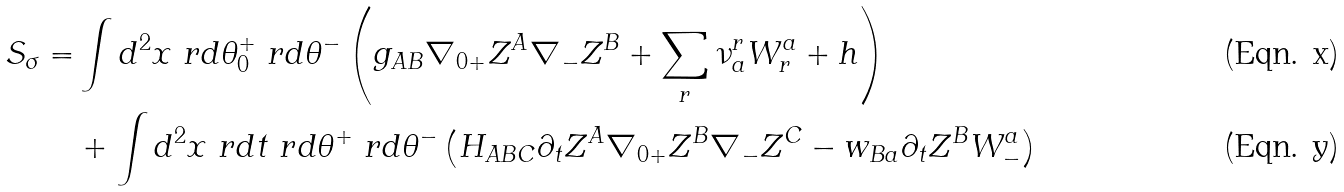<formula> <loc_0><loc_0><loc_500><loc_500>S _ { \sigma } = & \int d { ^ { 2 } x \ r d \theta _ { 0 } ^ { + } \ r d \theta ^ { - } } \left ( g _ { A B } \nabla _ { 0 + } Z ^ { A } \nabla _ { - } Z ^ { B } + \sum _ { r } \nu ^ { r } _ { a } W ^ { a } _ { r } + h \right ) \\ & + \int d { ^ { 2 } x \ r d t \ r d \theta ^ { + } \ r d \theta ^ { - } } \left ( H _ { A B C } \partial _ { t } Z ^ { A } \nabla _ { 0 + } Z ^ { B } \nabla _ { - } Z ^ { C } - w _ { B a } \partial _ { t } Z ^ { B } W _ { - } ^ { a } \right )</formula> 